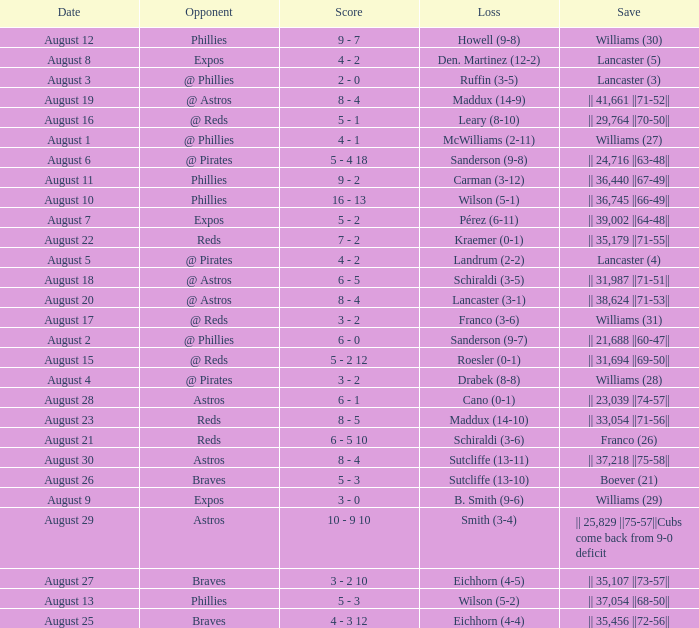Parse the full table. {'header': ['Date', 'Opponent', 'Score', 'Loss', 'Save'], 'rows': [['August 12', 'Phillies', '9 - 7', 'Howell (9-8)', 'Williams (30)'], ['August 8', 'Expos', '4 - 2', 'Den. Martinez (12-2)', 'Lancaster (5)'], ['August 3', '@ Phillies', '2 - 0', 'Ruffin (3-5)', 'Lancaster (3)'], ['August 19', '@ Astros', '8 - 4', 'Maddux (14-9)', '|| 41,661 ||71-52||'], ['August 16', '@ Reds', '5 - 1', 'Leary (8-10)', '|| 29,764 ||70-50||'], ['August 1', '@ Phillies', '4 - 1', 'McWilliams (2-11)', 'Williams (27)'], ['August 6', '@ Pirates', '5 - 4 18', 'Sanderson (9-8)', '|| 24,716 ||63-48||'], ['August 11', 'Phillies', '9 - 2', 'Carman (3-12)', '|| 36,440 ||67-49||'], ['August 10', 'Phillies', '16 - 13', 'Wilson (5-1)', '|| 36,745 ||66-49||'], ['August 7', 'Expos', '5 - 2', 'Pérez (6-11)', '|| 39,002 ||64-48||'], ['August 22', 'Reds', '7 - 2', 'Kraemer (0-1)', '|| 35,179 ||71-55||'], ['August 5', '@ Pirates', '4 - 2', 'Landrum (2-2)', 'Lancaster (4)'], ['August 18', '@ Astros', '6 - 5', 'Schiraldi (3-5)', '|| 31,987 ||71-51||'], ['August 20', '@ Astros', '8 - 4', 'Lancaster (3-1)', '|| 38,624 ||71-53||'], ['August 17', '@ Reds', '3 - 2', 'Franco (3-6)', 'Williams (31)'], ['August 2', '@ Phillies', '6 - 0', 'Sanderson (9-7)', '|| 21,688 ||60-47||'], ['August 15', '@ Reds', '5 - 2 12', 'Roesler (0-1)', '|| 31,694 ||69-50||'], ['August 4', '@ Pirates', '3 - 2', 'Drabek (8-8)', 'Williams (28)'], ['August 28', 'Astros', '6 - 1', 'Cano (0-1)', '|| 23,039 ||74-57||'], ['August 23', 'Reds', '8 - 5', 'Maddux (14-10)', '|| 33,054 ||71-56||'], ['August 21', 'Reds', '6 - 5 10', 'Schiraldi (3-6)', 'Franco (26)'], ['August 30', 'Astros', '8 - 4', 'Sutcliffe (13-11)', '|| 37,218 ||75-58||'], ['August 26', 'Braves', '5 - 3', 'Sutcliffe (13-10)', 'Boever (21)'], ['August 9', 'Expos', '3 - 0', 'B. Smith (9-6)', 'Williams (29)'], ['August 29', 'Astros', '10 - 9 10', 'Smith (3-4)', '|| 25,829 ||75-57||Cubs come back from 9-0 deficit'], ['August 27', 'Braves', '3 - 2 10', 'Eichhorn (4-5)', '|| 35,107 ||73-57||'], ['August 13', 'Phillies', '5 - 3', 'Wilson (5-2)', '|| 37,054 ||68-50||'], ['August 25', 'Braves', '4 - 3 12', 'Eichhorn (4-4)', '|| 35,456 ||72-56||']]} Name the opponent with loss of sanderson (9-8) @ Pirates. 